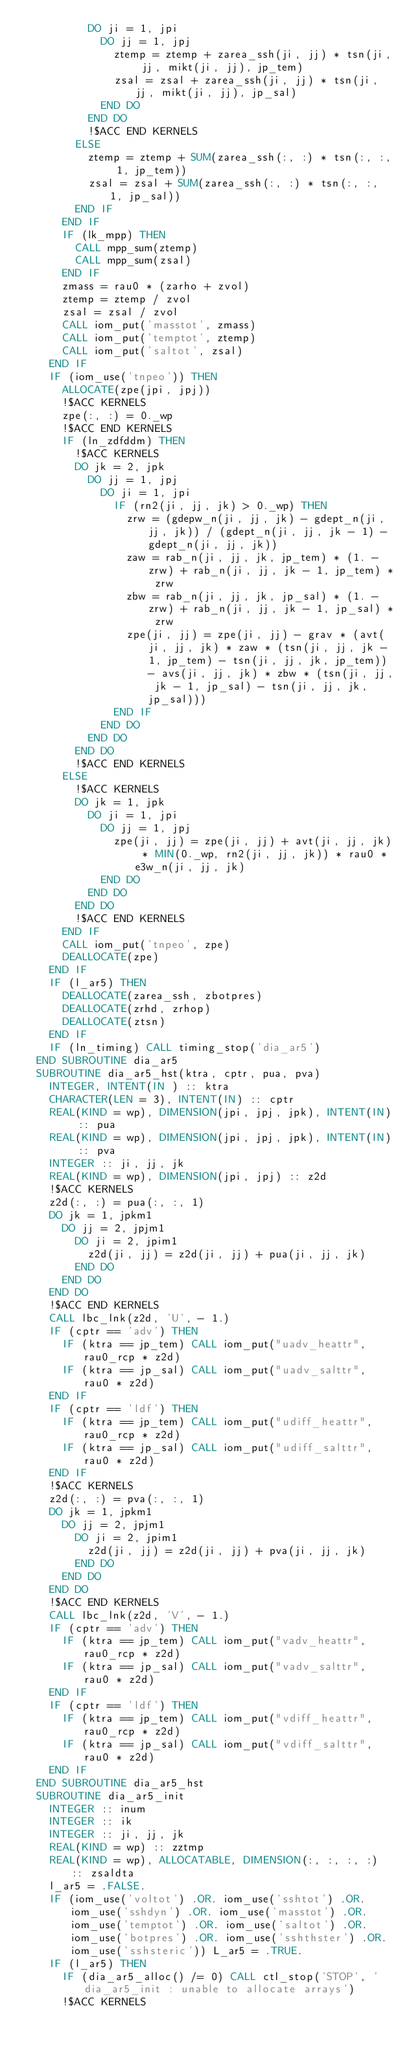<code> <loc_0><loc_0><loc_500><loc_500><_FORTRAN_>          DO ji = 1, jpi
            DO jj = 1, jpj
              ztemp = ztemp + zarea_ssh(ji, jj) * tsn(ji, jj, mikt(ji, jj), jp_tem)
              zsal = zsal + zarea_ssh(ji, jj) * tsn(ji, jj, mikt(ji, jj), jp_sal)
            END DO
          END DO
          !$ACC END KERNELS
        ELSE
          ztemp = ztemp + SUM(zarea_ssh(:, :) * tsn(:, :, 1, jp_tem))
          zsal = zsal + SUM(zarea_ssh(:, :) * tsn(:, :, 1, jp_sal))
        END IF
      END IF
      IF (lk_mpp) THEN
        CALL mpp_sum(ztemp)
        CALL mpp_sum(zsal)
      END IF
      zmass = rau0 * (zarho + zvol)
      ztemp = ztemp / zvol
      zsal = zsal / zvol
      CALL iom_put('masstot', zmass)
      CALL iom_put('temptot', ztemp)
      CALL iom_put('saltot', zsal)
    END IF
    IF (iom_use('tnpeo')) THEN
      ALLOCATE(zpe(jpi, jpj))
      !$ACC KERNELS
      zpe(:, :) = 0._wp
      !$ACC END KERNELS
      IF (ln_zdfddm) THEN
        !$ACC KERNELS
        DO jk = 2, jpk
          DO jj = 1, jpj
            DO ji = 1, jpi
              IF (rn2(ji, jj, jk) > 0._wp) THEN
                zrw = (gdepw_n(ji, jj, jk) - gdept_n(ji, jj, jk)) / (gdept_n(ji, jj, jk - 1) - gdept_n(ji, jj, jk))
                zaw = rab_n(ji, jj, jk, jp_tem) * (1. - zrw) + rab_n(ji, jj, jk - 1, jp_tem) * zrw
                zbw = rab_n(ji, jj, jk, jp_sal) * (1. - zrw) + rab_n(ji, jj, jk - 1, jp_sal) * zrw
                zpe(ji, jj) = zpe(ji, jj) - grav * (avt(ji, jj, jk) * zaw * (tsn(ji, jj, jk - 1, jp_tem) - tsn(ji, jj, jk, jp_tem)) - avs(ji, jj, jk) * zbw * (tsn(ji, jj, jk - 1, jp_sal) - tsn(ji, jj, jk, jp_sal)))
              END IF
            END DO
          END DO
        END DO
        !$ACC END KERNELS
      ELSE
        !$ACC KERNELS
        DO jk = 1, jpk
          DO ji = 1, jpi
            DO jj = 1, jpj
              zpe(ji, jj) = zpe(ji, jj) + avt(ji, jj, jk) * MIN(0._wp, rn2(ji, jj, jk)) * rau0 * e3w_n(ji, jj, jk)
            END DO
          END DO
        END DO
        !$ACC END KERNELS
      END IF
      CALL iom_put('tnpeo', zpe)
      DEALLOCATE(zpe)
    END IF
    IF (l_ar5) THEN
      DEALLOCATE(zarea_ssh, zbotpres)
      DEALLOCATE(zrhd, zrhop)
      DEALLOCATE(ztsn)
    END IF
    IF (ln_timing) CALL timing_stop('dia_ar5')
  END SUBROUTINE dia_ar5
  SUBROUTINE dia_ar5_hst(ktra, cptr, pua, pva)
    INTEGER, INTENT(IN ) :: ktra
    CHARACTER(LEN = 3), INTENT(IN) :: cptr
    REAL(KIND = wp), DIMENSION(jpi, jpj, jpk), INTENT(IN) :: pua
    REAL(KIND = wp), DIMENSION(jpi, jpj, jpk), INTENT(IN) :: pva
    INTEGER :: ji, jj, jk
    REAL(KIND = wp), DIMENSION(jpi, jpj) :: z2d
    !$ACC KERNELS
    z2d(:, :) = pua(:, :, 1)
    DO jk = 1, jpkm1
      DO jj = 2, jpjm1
        DO ji = 2, jpim1
          z2d(ji, jj) = z2d(ji, jj) + pua(ji, jj, jk)
        END DO
      END DO
    END DO
    !$ACC END KERNELS
    CALL lbc_lnk(z2d, 'U', - 1.)
    IF (cptr == 'adv') THEN
      IF (ktra == jp_tem) CALL iom_put("uadv_heattr", rau0_rcp * z2d)
      IF (ktra == jp_sal) CALL iom_put("uadv_salttr", rau0 * z2d)
    END IF
    IF (cptr == 'ldf') THEN
      IF (ktra == jp_tem) CALL iom_put("udiff_heattr", rau0_rcp * z2d)
      IF (ktra == jp_sal) CALL iom_put("udiff_salttr", rau0 * z2d)
    END IF
    !$ACC KERNELS
    z2d(:, :) = pva(:, :, 1)
    DO jk = 1, jpkm1
      DO jj = 2, jpjm1
        DO ji = 2, jpim1
          z2d(ji, jj) = z2d(ji, jj) + pva(ji, jj, jk)
        END DO
      END DO
    END DO
    !$ACC END KERNELS
    CALL lbc_lnk(z2d, 'V', - 1.)
    IF (cptr == 'adv') THEN
      IF (ktra == jp_tem) CALL iom_put("vadv_heattr", rau0_rcp * z2d)
      IF (ktra == jp_sal) CALL iom_put("vadv_salttr", rau0 * z2d)
    END IF
    IF (cptr == 'ldf') THEN
      IF (ktra == jp_tem) CALL iom_put("vdiff_heattr", rau0_rcp * z2d)
      IF (ktra == jp_sal) CALL iom_put("vdiff_salttr", rau0 * z2d)
    END IF
  END SUBROUTINE dia_ar5_hst
  SUBROUTINE dia_ar5_init
    INTEGER :: inum
    INTEGER :: ik
    INTEGER :: ji, jj, jk
    REAL(KIND = wp) :: zztmp
    REAL(KIND = wp), ALLOCATABLE, DIMENSION(:, :, :, :) :: zsaldta
    l_ar5 = .FALSE.
    IF (iom_use('voltot') .OR. iom_use('sshtot') .OR. iom_use('sshdyn') .OR. iom_use('masstot') .OR. iom_use('temptot') .OR. iom_use('saltot') .OR. iom_use('botpres') .OR. iom_use('sshthster') .OR. iom_use('sshsteric')) L_ar5 = .TRUE.
    IF (l_ar5) THEN
      IF (dia_ar5_alloc() /= 0) CALL ctl_stop('STOP', 'dia_ar5_init : unable to allocate arrays')
      !$ACC KERNELS</code> 